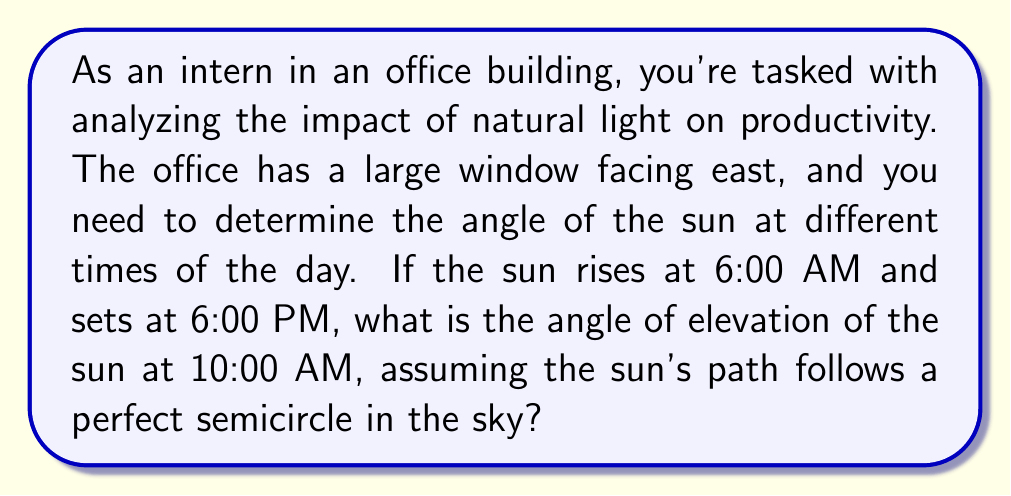Solve this math problem. To solve this problem, we need to approach it step-by-step using trigonometry:

1. First, let's visualize the sun's path as a semicircle:

[asy]
import geometry;

size(200);
pair O=(0,0);
draw((-1,0)--(1,0));
draw(arc(O,1,0,180));
draw(O--(0,1),dashed);
draw(O--(cos(60),sin(60)),Arrow);
label("Horizon",(-1,0),W);
label("Zenith",(0,1),N);
label("Sun at 10:00 AM",(cos(60),sin(60)),NE);
label("θ",(0.2,0),N);
[/asy]

2. The sun's path from sunrise to sunset spans 12 hours, which corresponds to 180° in our semicircle model.

3. We need to find out how many degrees the sun has traveled from 6:00 AM to 10:00 AM:
   - Time elapsed = 10:00 AM - 6:00 AM = 4 hours
   - Proportion of total time: $\frac{4 \text{ hours}}{12 \text{ hours}} = \frac{1}{3}$

4. The angle traveled in this time:
   $\theta = \frac{1}{3} \times 180° = 60°$

5. In our semicircle model, this 60° represents the angle from the eastern horizon to the sun's position at 10:00 AM.

6. The angle of elevation is the complementary angle to this:
   $\text{Angle of elevation} = 90° - 60° = 30°$

Therefore, the angle of elevation of the sun at 10:00 AM is 30°.
Answer: The angle of elevation of the sun at 10:00 AM is $30°$. 